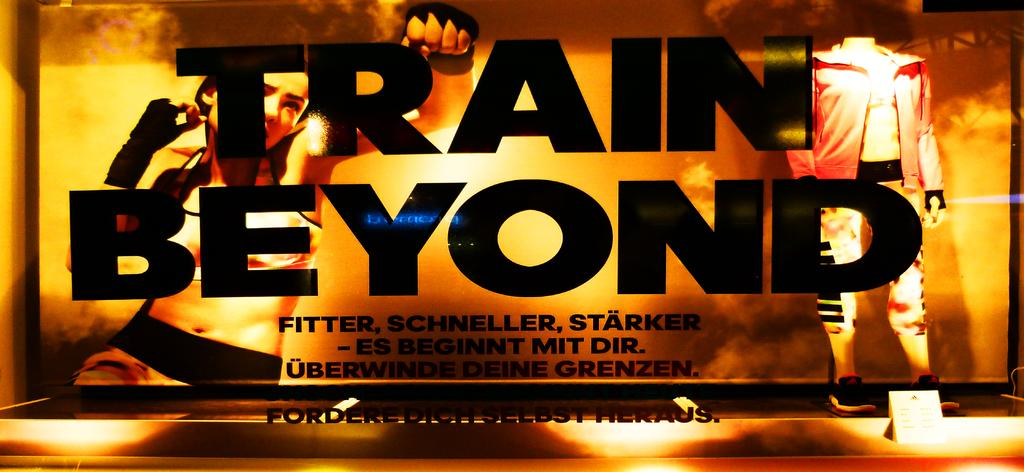<image>
Relay a brief, clear account of the picture shown. A kickboxing banner with the slogan "Train Beyond" 